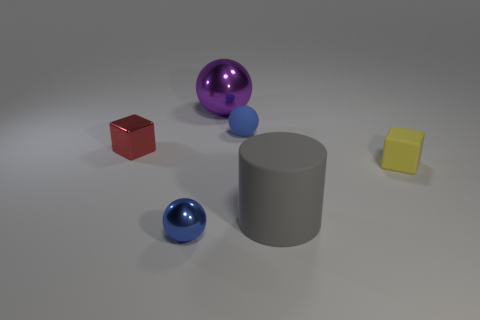Is the color of the big metal ball the same as the tiny matte object on the right side of the big gray cylinder?
Give a very brief answer. No. There is a metallic ball that is behind the blue object right of the purple shiny object; what is its color?
Keep it short and to the point. Purple. There is a small block that is on the left side of the tiny blue thing in front of the small red thing; is there a tiny red shiny object on the right side of it?
Keep it short and to the point. No. What color is the other small object that is the same material as the red thing?
Ensure brevity in your answer.  Blue. How many small blue things are made of the same material as the purple thing?
Make the answer very short. 1. Is the purple thing made of the same material as the small ball that is in front of the yellow thing?
Offer a terse response. Yes. What number of objects are either matte objects that are to the right of the cylinder or large purple shiny spheres?
Your answer should be very brief. 2. There is a block that is to the right of the matte object behind the small shiny object that is behind the yellow rubber object; what size is it?
Your response must be concise. Small. What is the material of the other sphere that is the same color as the tiny matte ball?
Provide a succinct answer. Metal. Is there any other thing that has the same shape as the large matte thing?
Make the answer very short. No. 